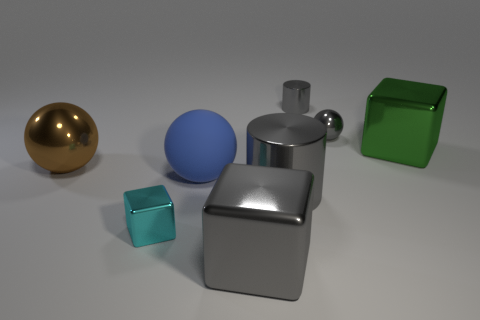Do the tiny cylinder and the large metallic cylinder have the same color?
Give a very brief answer. Yes. The small thing that is the same color as the small ball is what shape?
Give a very brief answer. Cylinder. Do the cylinder that is behind the blue object and the large block that is in front of the large cylinder have the same color?
Offer a very short reply. Yes. What number of large things are the same color as the tiny metal ball?
Your answer should be very brief. 2. What is the material of the blue ball that is behind the big gray object behind the large metal block in front of the large green metallic thing?
Your response must be concise. Rubber. How many tiny things are either cyan metal things or gray objects?
Your answer should be very brief. 3. Is the cylinder that is behind the blue matte ball made of the same material as the big ball that is to the right of the cyan metallic cube?
Offer a terse response. No. What is the big ball behind the large blue thing made of?
Your answer should be very brief. Metal. How many shiny things are either large green objects or large cubes?
Offer a very short reply. 2. The small metal cube to the left of the sphere behind the green object is what color?
Provide a short and direct response. Cyan. 